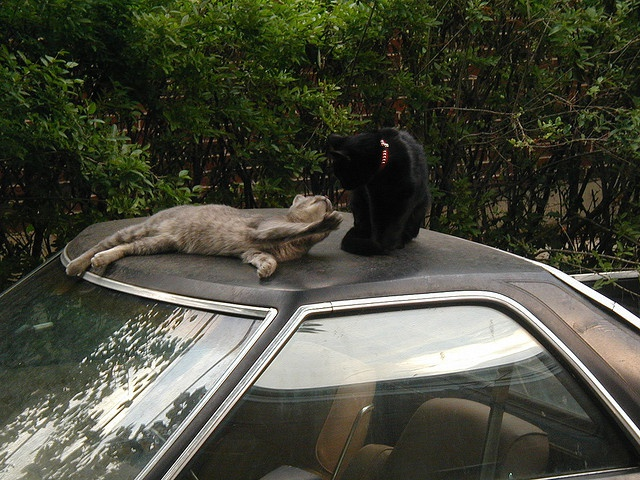Describe the objects in this image and their specific colors. I can see car in black, gray, lightgray, and darkgray tones, cat in black, gray, and darkgray tones, and cat in black, gray, and maroon tones in this image. 